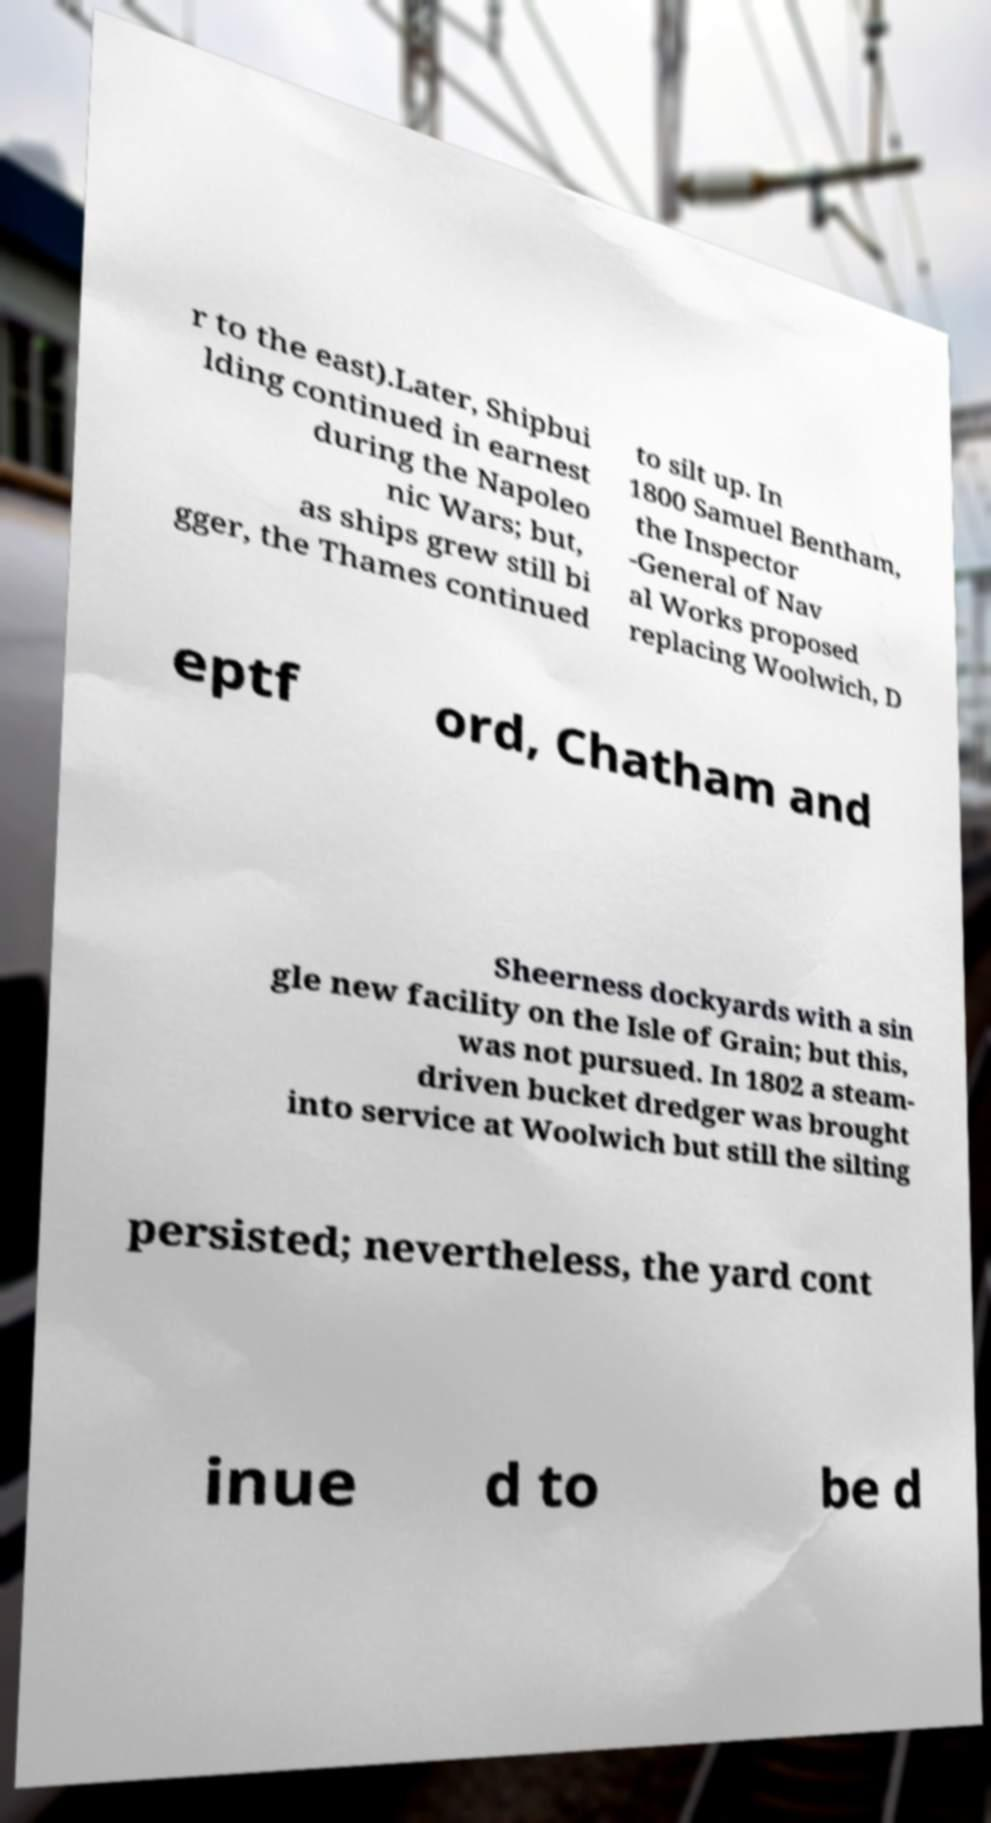Could you assist in decoding the text presented in this image and type it out clearly? r to the east).Later, Shipbui lding continued in earnest during the Napoleo nic Wars; but, as ships grew still bi gger, the Thames continued to silt up. In 1800 Samuel Bentham, the Inspector -General of Nav al Works proposed replacing Woolwich, D eptf ord, Chatham and Sheerness dockyards with a sin gle new facility on the Isle of Grain; but this, was not pursued. In 1802 a steam- driven bucket dredger was brought into service at Woolwich but still the silting persisted; nevertheless, the yard cont inue d to be d 